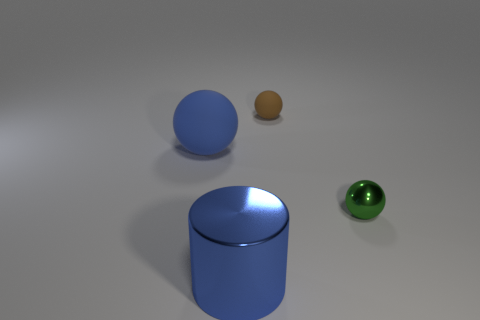Add 3 cyan cylinders. How many objects exist? 7 Subtract all balls. How many objects are left? 1 Subtract all large green rubber cylinders. Subtract all metallic balls. How many objects are left? 3 Add 3 tiny metal objects. How many tiny metal objects are left? 4 Add 4 yellow shiny cylinders. How many yellow shiny cylinders exist? 4 Subtract 0 gray balls. How many objects are left? 4 